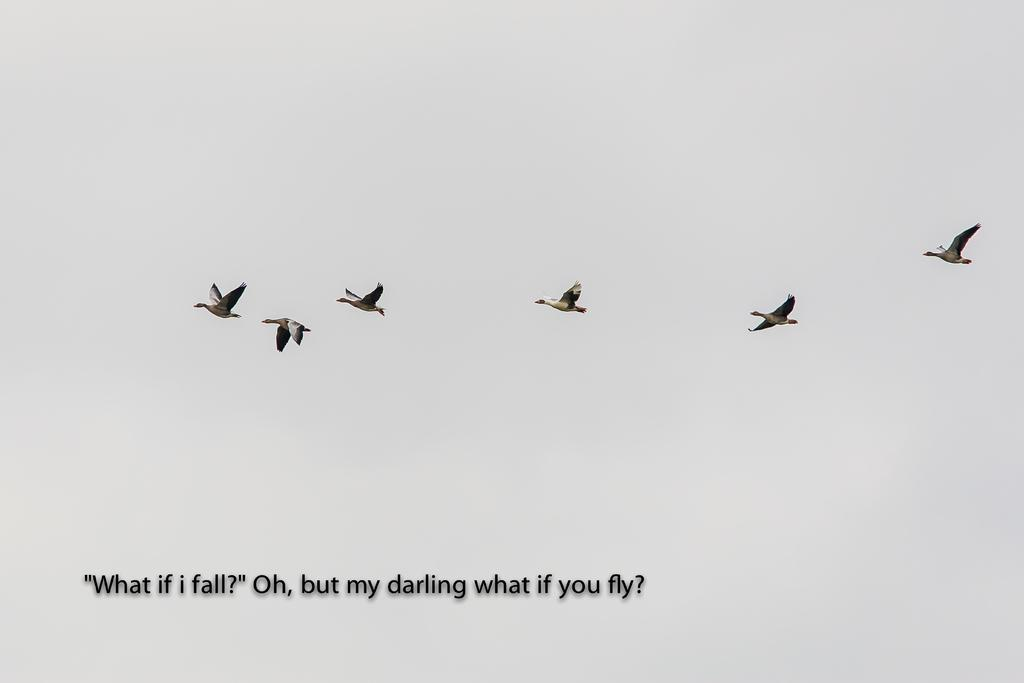What is happening in the sky in the image? There are birds flying in the sky in the image. What else can be seen in the image besides the birds? There are texts written on the image. Where is the grandmother sitting in the image? There is no grandmother present in the image. What type of whistle can be heard in the image? There is no whistle present in the image, and therefore no sound can be heard. 